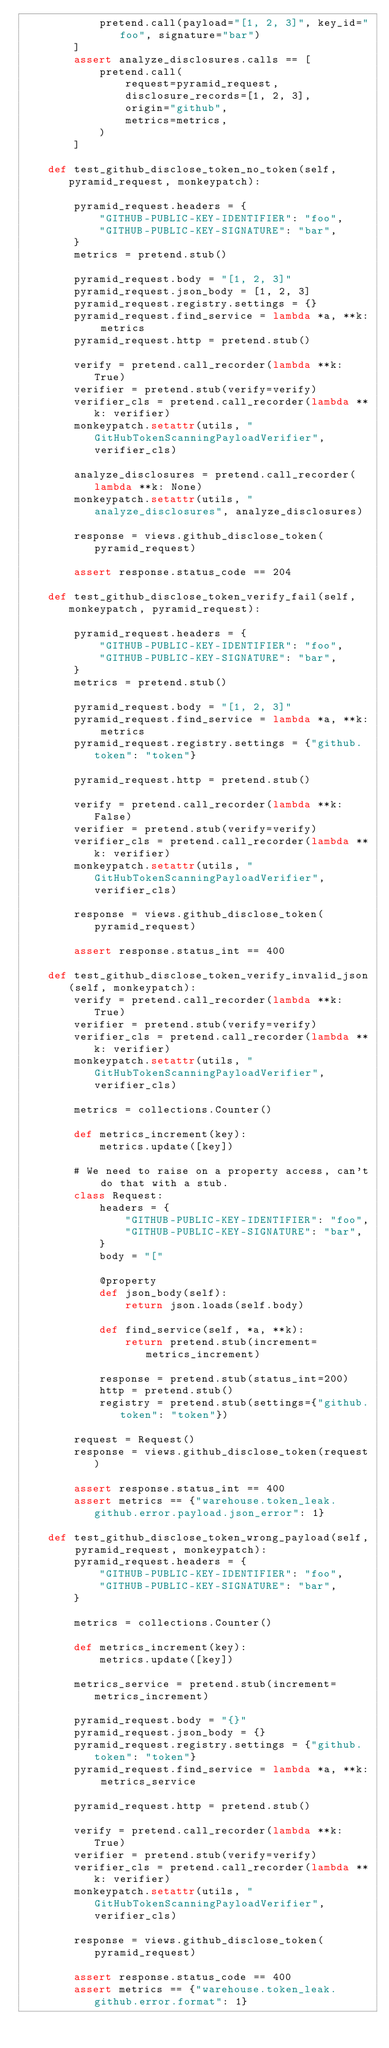<code> <loc_0><loc_0><loc_500><loc_500><_Python_>            pretend.call(payload="[1, 2, 3]", key_id="foo", signature="bar")
        ]
        assert analyze_disclosures.calls == [
            pretend.call(
                request=pyramid_request,
                disclosure_records=[1, 2, 3],
                origin="github",
                metrics=metrics,
            )
        ]

    def test_github_disclose_token_no_token(self, pyramid_request, monkeypatch):

        pyramid_request.headers = {
            "GITHUB-PUBLIC-KEY-IDENTIFIER": "foo",
            "GITHUB-PUBLIC-KEY-SIGNATURE": "bar",
        }
        metrics = pretend.stub()

        pyramid_request.body = "[1, 2, 3]"
        pyramid_request.json_body = [1, 2, 3]
        pyramid_request.registry.settings = {}
        pyramid_request.find_service = lambda *a, **k: metrics
        pyramid_request.http = pretend.stub()

        verify = pretend.call_recorder(lambda **k: True)
        verifier = pretend.stub(verify=verify)
        verifier_cls = pretend.call_recorder(lambda **k: verifier)
        monkeypatch.setattr(utils, "GitHubTokenScanningPayloadVerifier", verifier_cls)

        analyze_disclosures = pretend.call_recorder(lambda **k: None)
        monkeypatch.setattr(utils, "analyze_disclosures", analyze_disclosures)

        response = views.github_disclose_token(pyramid_request)

        assert response.status_code == 204

    def test_github_disclose_token_verify_fail(self, monkeypatch, pyramid_request):

        pyramid_request.headers = {
            "GITHUB-PUBLIC-KEY-IDENTIFIER": "foo",
            "GITHUB-PUBLIC-KEY-SIGNATURE": "bar",
        }
        metrics = pretend.stub()

        pyramid_request.body = "[1, 2, 3]"
        pyramid_request.find_service = lambda *a, **k: metrics
        pyramid_request.registry.settings = {"github.token": "token"}

        pyramid_request.http = pretend.stub()

        verify = pretend.call_recorder(lambda **k: False)
        verifier = pretend.stub(verify=verify)
        verifier_cls = pretend.call_recorder(lambda **k: verifier)
        monkeypatch.setattr(utils, "GitHubTokenScanningPayloadVerifier", verifier_cls)

        response = views.github_disclose_token(pyramid_request)

        assert response.status_int == 400

    def test_github_disclose_token_verify_invalid_json(self, monkeypatch):
        verify = pretend.call_recorder(lambda **k: True)
        verifier = pretend.stub(verify=verify)
        verifier_cls = pretend.call_recorder(lambda **k: verifier)
        monkeypatch.setattr(utils, "GitHubTokenScanningPayloadVerifier", verifier_cls)

        metrics = collections.Counter()

        def metrics_increment(key):
            metrics.update([key])

        # We need to raise on a property access, can't do that with a stub.
        class Request:
            headers = {
                "GITHUB-PUBLIC-KEY-IDENTIFIER": "foo",
                "GITHUB-PUBLIC-KEY-SIGNATURE": "bar",
            }
            body = "["

            @property
            def json_body(self):
                return json.loads(self.body)

            def find_service(self, *a, **k):
                return pretend.stub(increment=metrics_increment)

            response = pretend.stub(status_int=200)
            http = pretend.stub()
            registry = pretend.stub(settings={"github.token": "token"})

        request = Request()
        response = views.github_disclose_token(request)

        assert response.status_int == 400
        assert metrics == {"warehouse.token_leak.github.error.payload.json_error": 1}

    def test_github_disclose_token_wrong_payload(self, pyramid_request, monkeypatch):
        pyramid_request.headers = {
            "GITHUB-PUBLIC-KEY-IDENTIFIER": "foo",
            "GITHUB-PUBLIC-KEY-SIGNATURE": "bar",
        }

        metrics = collections.Counter()

        def metrics_increment(key):
            metrics.update([key])

        metrics_service = pretend.stub(increment=metrics_increment)

        pyramid_request.body = "{}"
        pyramid_request.json_body = {}
        pyramid_request.registry.settings = {"github.token": "token"}
        pyramid_request.find_service = lambda *a, **k: metrics_service

        pyramid_request.http = pretend.stub()

        verify = pretend.call_recorder(lambda **k: True)
        verifier = pretend.stub(verify=verify)
        verifier_cls = pretend.call_recorder(lambda **k: verifier)
        monkeypatch.setattr(utils, "GitHubTokenScanningPayloadVerifier", verifier_cls)

        response = views.github_disclose_token(pyramid_request)

        assert response.status_code == 400
        assert metrics == {"warehouse.token_leak.github.error.format": 1}
</code> 